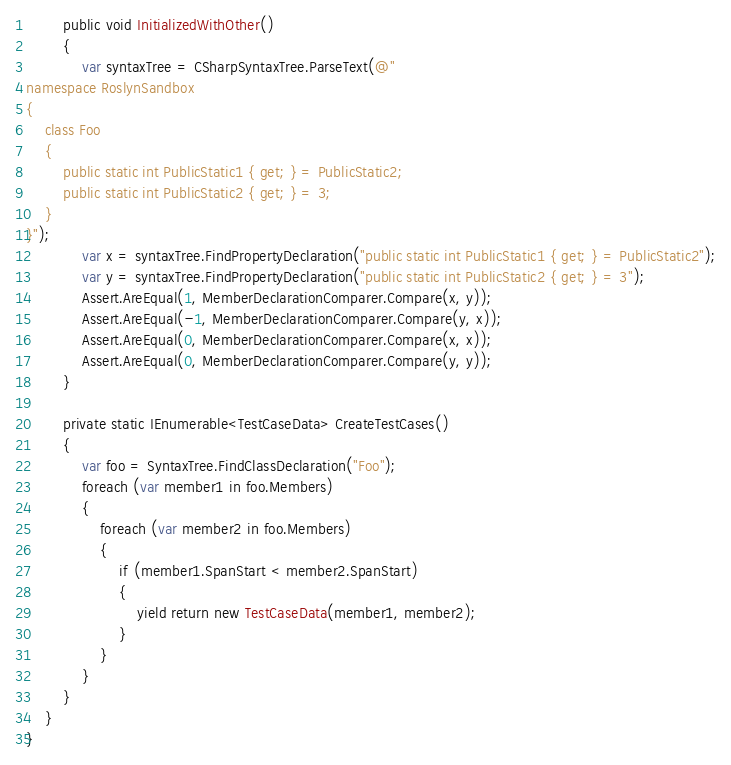<code> <loc_0><loc_0><loc_500><loc_500><_C#_>        public void InitializedWithOther()
        {
            var syntaxTree = CSharpSyntaxTree.ParseText(@"
namespace RoslynSandbox
{
    class Foo
    {
        public static int PublicStatic1 { get; } = PublicStatic2;
        public static int PublicStatic2 { get; } = 3;
    }
}");
            var x = syntaxTree.FindPropertyDeclaration("public static int PublicStatic1 { get; } = PublicStatic2");
            var y = syntaxTree.FindPropertyDeclaration("public static int PublicStatic2 { get; } = 3");
            Assert.AreEqual(1, MemberDeclarationComparer.Compare(x, y));
            Assert.AreEqual(-1, MemberDeclarationComparer.Compare(y, x));
            Assert.AreEqual(0, MemberDeclarationComparer.Compare(x, x));
            Assert.AreEqual(0, MemberDeclarationComparer.Compare(y, y));
        }

        private static IEnumerable<TestCaseData> CreateTestCases()
        {
            var foo = SyntaxTree.FindClassDeclaration("Foo");
            foreach (var member1 in foo.Members)
            {
                foreach (var member2 in foo.Members)
                {
                    if (member1.SpanStart < member2.SpanStart)
                    {
                        yield return new TestCaseData(member1, member2);
                    }
                }
            }
        }
    }
}
</code> 